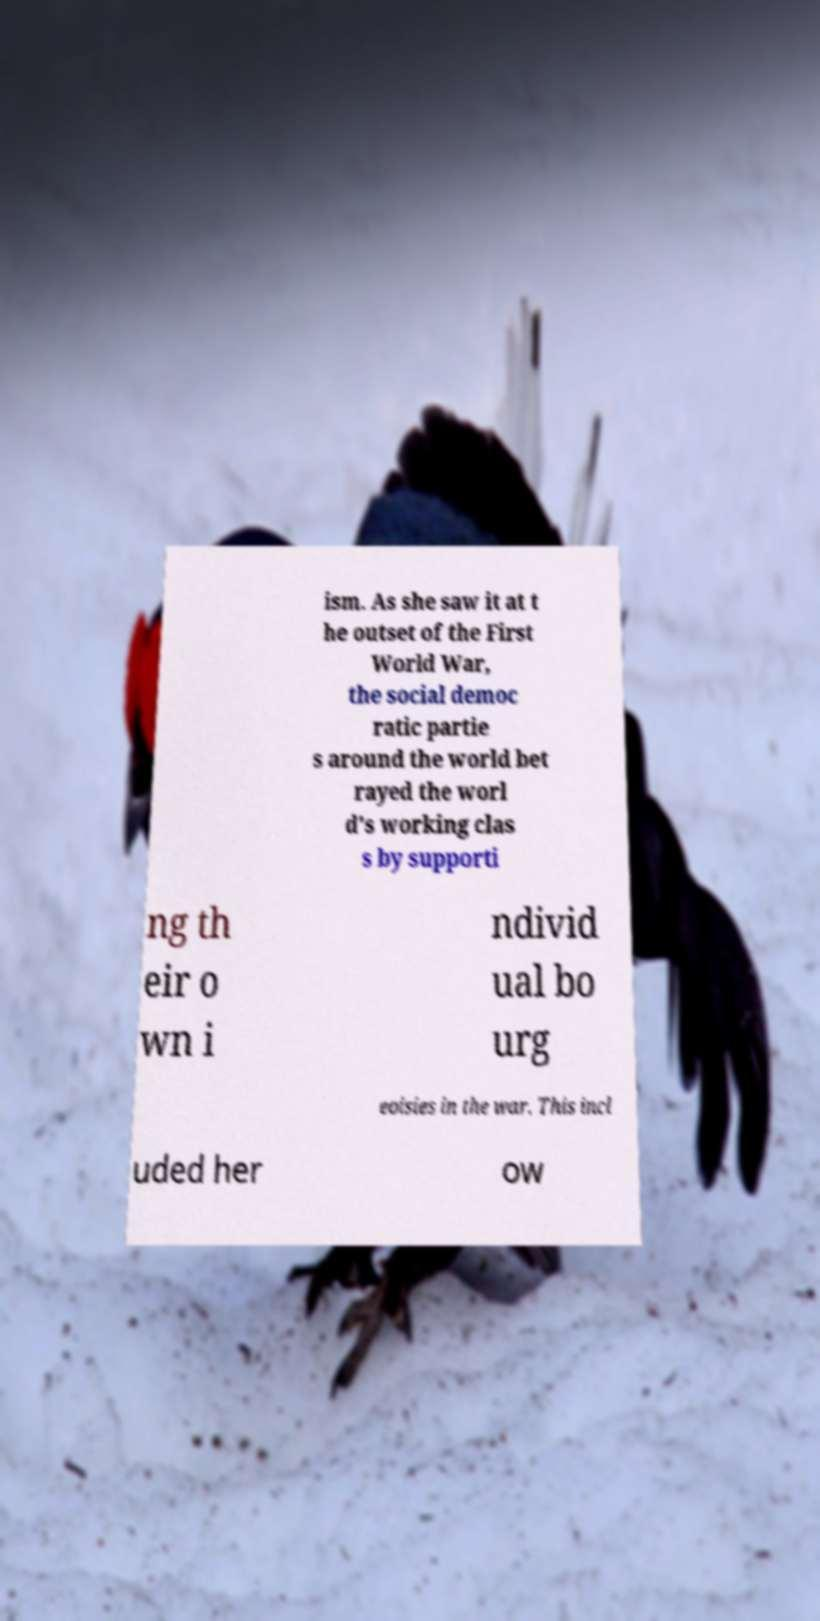Please identify and transcribe the text found in this image. ism. As she saw it at t he outset of the First World War, the social democ ratic partie s around the world bet rayed the worl d's working clas s by supporti ng th eir o wn i ndivid ual bo urg eoisies in the war. This incl uded her ow 